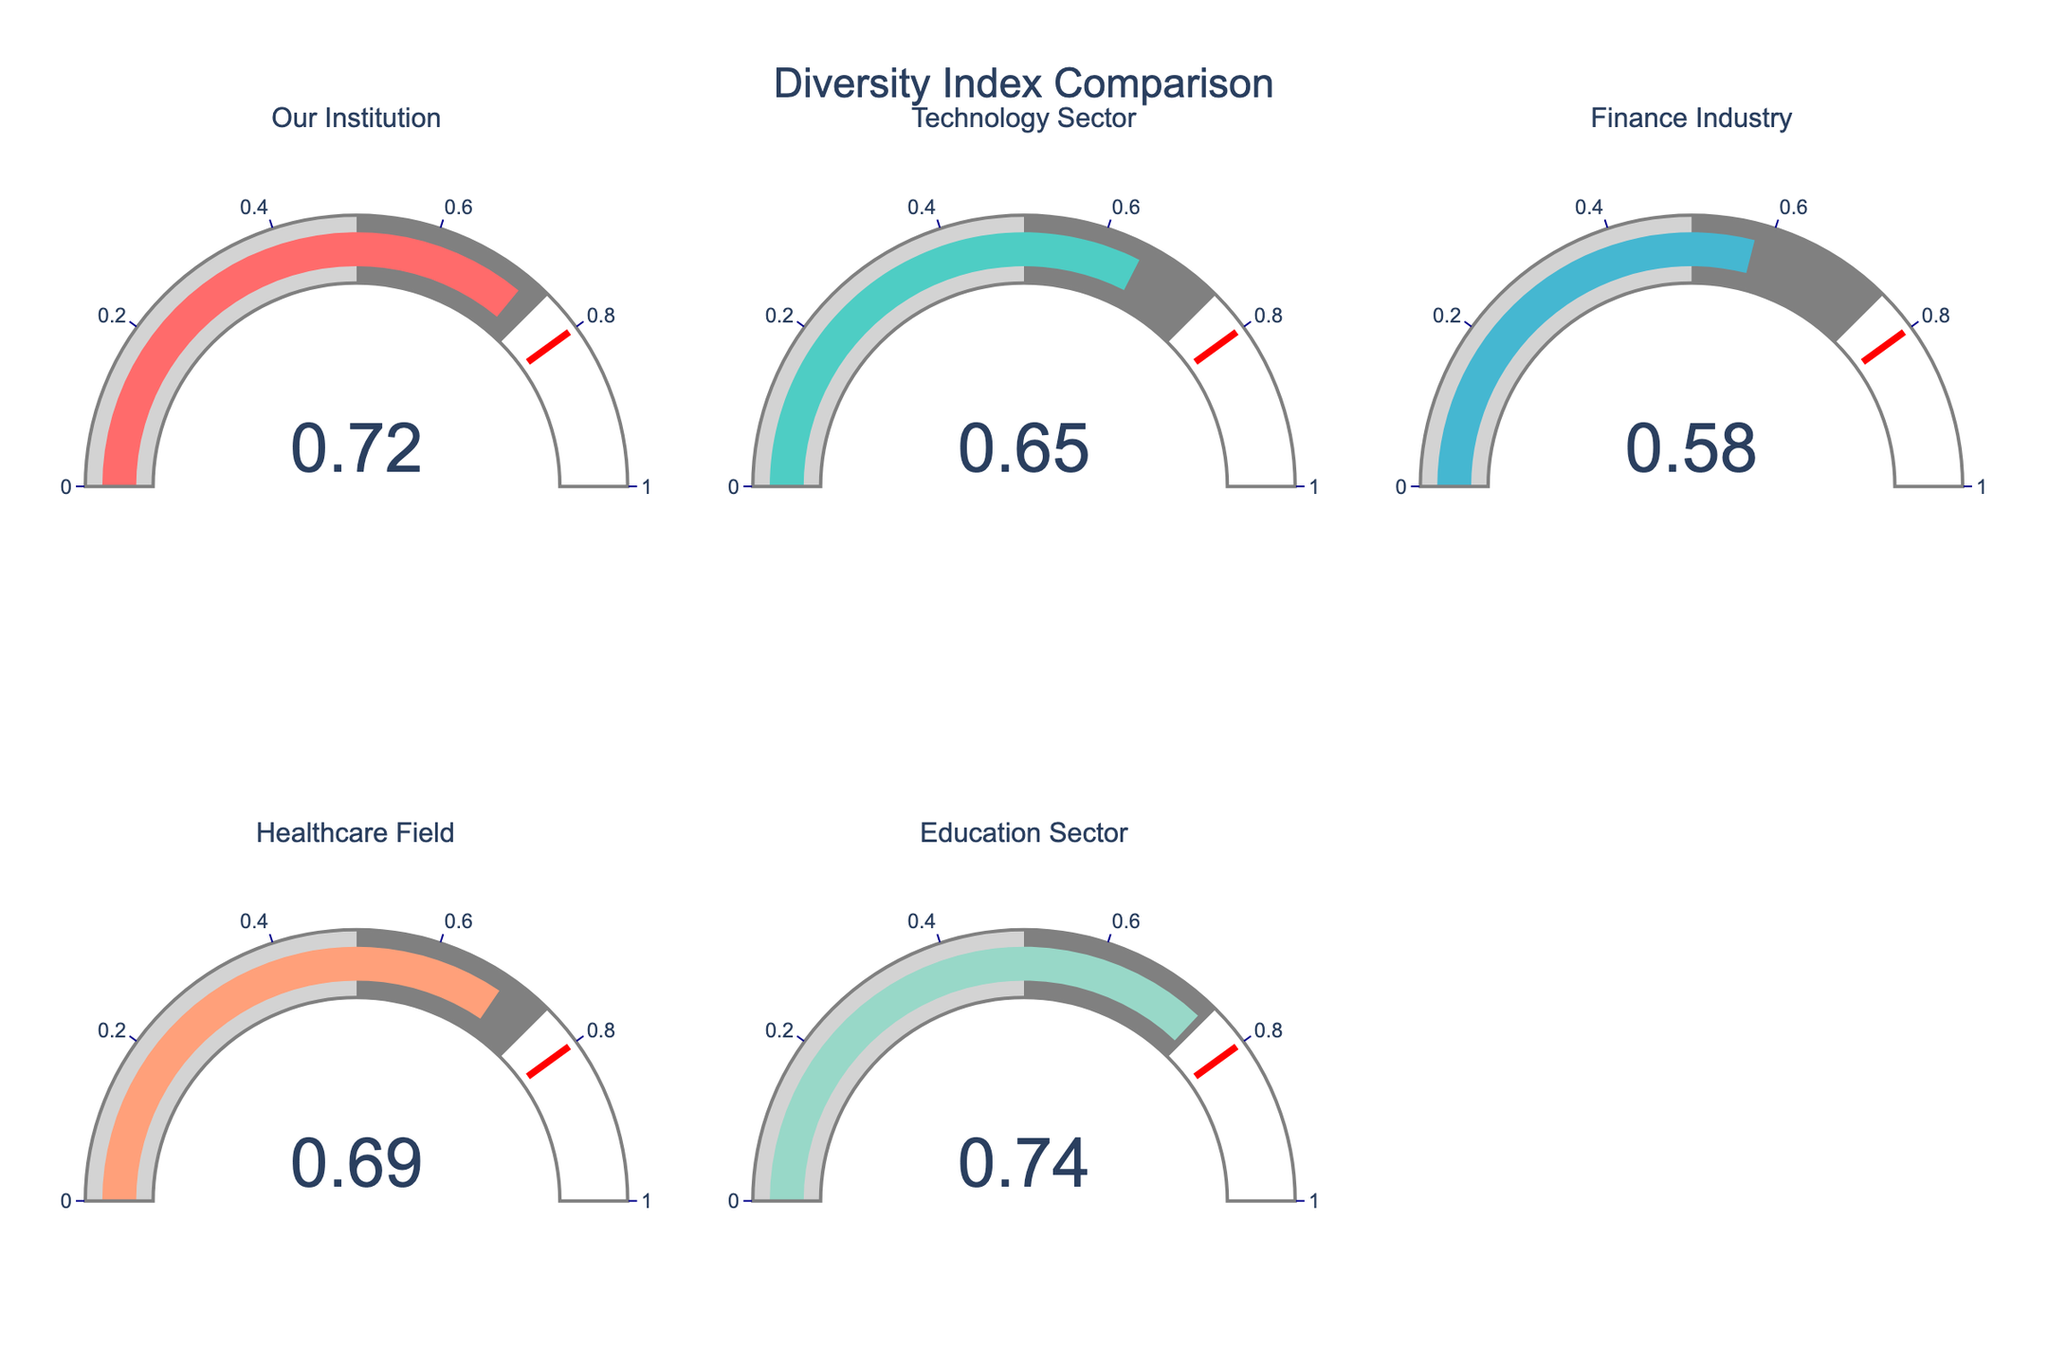What is the diversity index of our institution? The gauge chart for "Our Institution" shows the value directly inside the gauge's number display.
Answer: 0.72 Which industry has the lowest diversity index? By comparing the numbers displayed in each gauge, the Finance Industry has the lowest value.
Answer: Finance Industry How does our institution's diversity index compare to the Technology Sector? The diversity index of our institution is 0.72, while the Technology Sector is 0.65. Therefore, our institution's index is higher.
Answer: higher What is the average diversity index of the five industries presented in the figure? Summing up the diversity indices: 0.72 (Our Institution) + 0.65 (Technology Sector) + 0.58 (Finance Industry) + 0.69 (Healthcare Field) + 0.74 (Education Sector) = 3.38. The average is 3.38/5 = 0.676.
Answer: 0.676 Does any industry have a higher diversity index than our institution? Comparing all indices, the Education Sector (0.74) has a higher diversity index than our institution (0.72).
Answer: Yes Which industry is closest to the threshold value indicated in the gauges? The gauges have a red threshold marker at 0.8. The Education Sector has the highest value at 0.74, which is closest to the threshold.
Answer: Education Sector What is the diversity index difference between the highest and the lowest industries? The highest diversity index is 0.74 (Education Sector), and the lowest is 0.58 (Finance Industry). The difference is 0.74 - 0.58 = 0.16.
Answer: 0.16 Identify the industry with a diversity index closest to 0.70. Comparing the indices, the Healthcare Field has a diversity index of 0.69, which is the closest to 0.70.
Answer: Healthcare Field How many industries have a diversity index above 0.60? Checking each gauge, four industries have indices above 0.60: Our Institution (0.72), Technology Sector (0.65), Healthcare Field (0.69), and Education Sector (0.74).
Answer: 4 What is the second highest diversity index among the industries? The indices in descending order are 0.74 (Education Sector), 0.72 (Our Institution), 0.69 (Healthcare Field), 0.65 (Technology Sector), and 0.58 (Finance Industry). The second highest is 0.72.
Answer: 0.72 